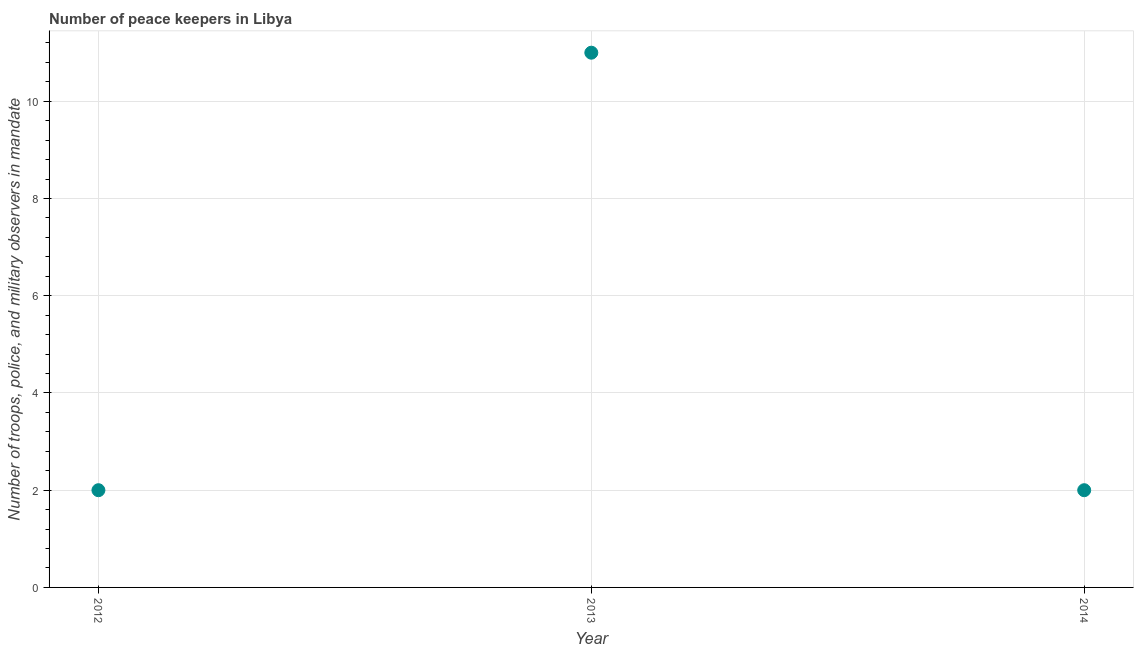What is the number of peace keepers in 2013?
Your answer should be very brief. 11. Across all years, what is the maximum number of peace keepers?
Your response must be concise. 11. Across all years, what is the minimum number of peace keepers?
Make the answer very short. 2. In which year was the number of peace keepers maximum?
Your answer should be compact. 2013. What is the sum of the number of peace keepers?
Offer a very short reply. 15. What is the difference between the number of peace keepers in 2012 and 2013?
Your answer should be very brief. -9. What is the average number of peace keepers per year?
Offer a very short reply. 5. In how many years, is the number of peace keepers greater than 6.8 ?
Give a very brief answer. 1. Do a majority of the years between 2012 and 2014 (inclusive) have number of peace keepers greater than 6.8 ?
Your response must be concise. No. Is the number of peace keepers in 2012 less than that in 2013?
Provide a short and direct response. Yes. Is the sum of the number of peace keepers in 2013 and 2014 greater than the maximum number of peace keepers across all years?
Provide a succinct answer. Yes. What is the difference between the highest and the lowest number of peace keepers?
Offer a very short reply. 9. Does the number of peace keepers monotonically increase over the years?
Your response must be concise. No. How many dotlines are there?
Your response must be concise. 1. How many years are there in the graph?
Ensure brevity in your answer.  3. Does the graph contain grids?
Your answer should be very brief. Yes. What is the title of the graph?
Provide a succinct answer. Number of peace keepers in Libya. What is the label or title of the X-axis?
Offer a terse response. Year. What is the label or title of the Y-axis?
Ensure brevity in your answer.  Number of troops, police, and military observers in mandate. What is the Number of troops, police, and military observers in mandate in 2012?
Make the answer very short. 2. What is the Number of troops, police, and military observers in mandate in 2013?
Keep it short and to the point. 11. What is the Number of troops, police, and military observers in mandate in 2014?
Offer a very short reply. 2. What is the ratio of the Number of troops, police, and military observers in mandate in 2012 to that in 2013?
Ensure brevity in your answer.  0.18. What is the ratio of the Number of troops, police, and military observers in mandate in 2012 to that in 2014?
Give a very brief answer. 1. What is the ratio of the Number of troops, police, and military observers in mandate in 2013 to that in 2014?
Your response must be concise. 5.5. 